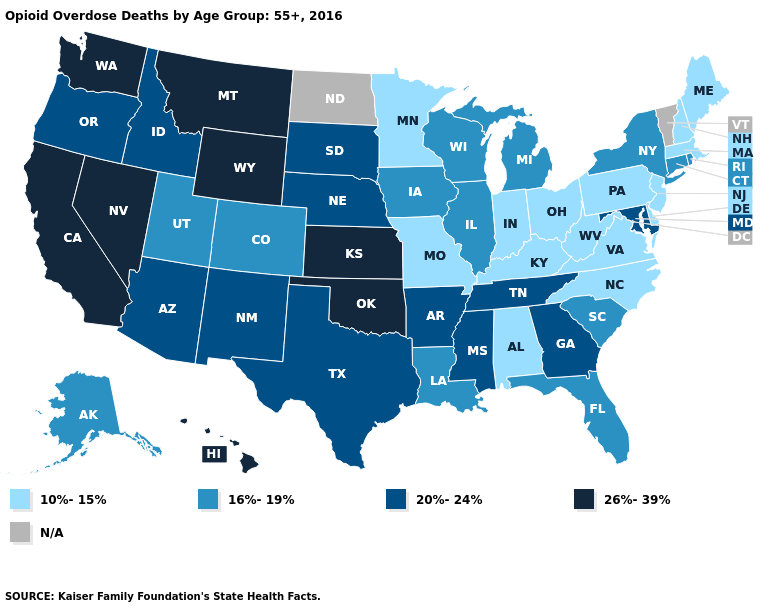Does the map have missing data?
Short answer required. Yes. What is the value of Arizona?
Write a very short answer. 20%-24%. Name the states that have a value in the range 20%-24%?
Short answer required. Arizona, Arkansas, Georgia, Idaho, Maryland, Mississippi, Nebraska, New Mexico, Oregon, South Dakota, Tennessee, Texas. Among the states that border Massachusetts , does Rhode Island have the highest value?
Answer briefly. Yes. Does New Hampshire have the highest value in the Northeast?
Concise answer only. No. What is the highest value in the MidWest ?
Concise answer only. 26%-39%. Which states have the lowest value in the USA?
Write a very short answer. Alabama, Delaware, Indiana, Kentucky, Maine, Massachusetts, Minnesota, Missouri, New Hampshire, New Jersey, North Carolina, Ohio, Pennsylvania, Virginia, West Virginia. Name the states that have a value in the range 26%-39%?
Give a very brief answer. California, Hawaii, Kansas, Montana, Nevada, Oklahoma, Washington, Wyoming. What is the highest value in the West ?
Answer briefly. 26%-39%. Does Wyoming have the highest value in the USA?
Keep it brief. Yes. What is the value of Utah?
Answer briefly. 16%-19%. What is the value of Oregon?
Give a very brief answer. 20%-24%. Does Alabama have the lowest value in the South?
Give a very brief answer. Yes. Which states have the lowest value in the West?
Answer briefly. Alaska, Colorado, Utah. Does Massachusetts have the lowest value in the USA?
Keep it brief. Yes. 